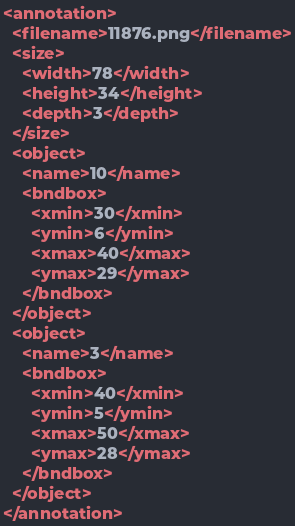Convert code to text. <code><loc_0><loc_0><loc_500><loc_500><_XML_><annotation>
  <filename>11876.png</filename>
  <size>
    <width>78</width>
    <height>34</height>
    <depth>3</depth>
  </size>
  <object>
    <name>10</name>
    <bndbox>
      <xmin>30</xmin>
      <ymin>6</ymin>
      <xmax>40</xmax>
      <ymax>29</ymax>
    </bndbox>
  </object>
  <object>
    <name>3</name>
    <bndbox>
      <xmin>40</xmin>
      <ymin>5</ymin>
      <xmax>50</xmax>
      <ymax>28</ymax>
    </bndbox>
  </object>
</annotation>
</code> 